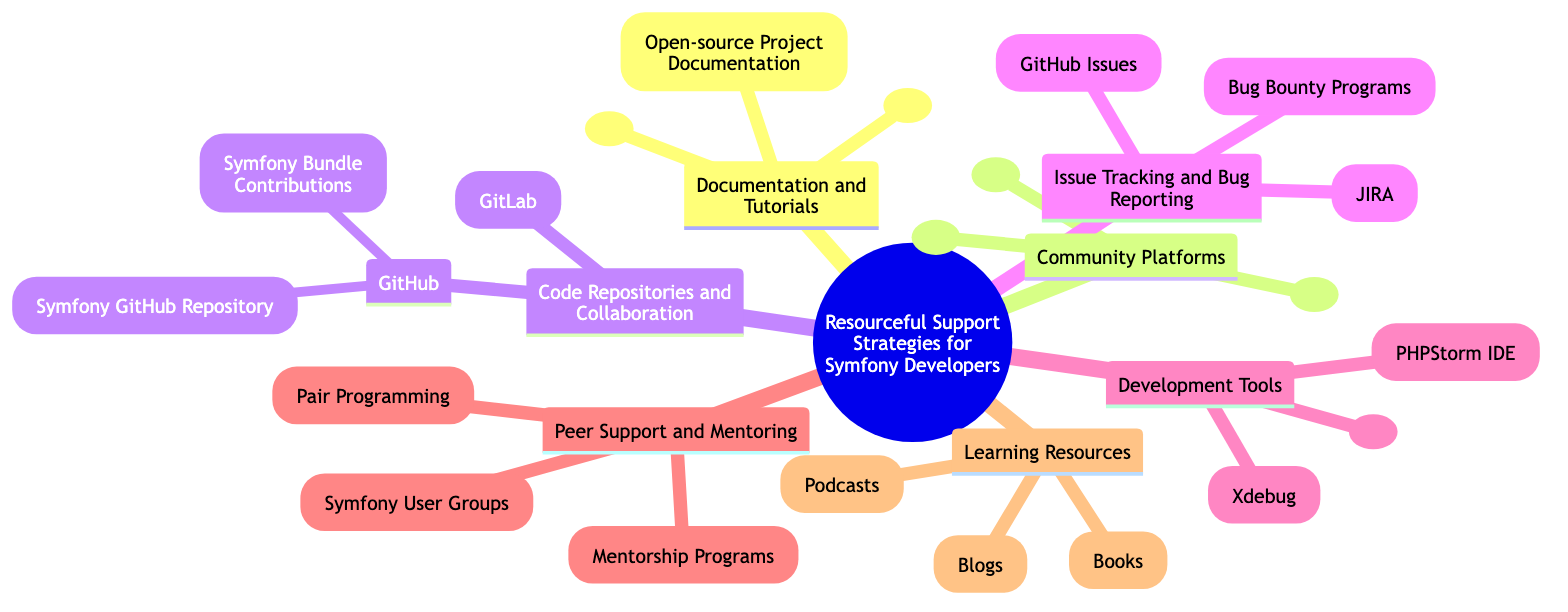What are the main areas of support strategies for Symfony developers? The main areas listed in the diagram include Documentation and Tutorials, Community Platforms, Code Repositories and Collaboration, Issue Tracking and Bug Reporting, Development Tools, Peer Support and Mentoring, and Learning Resources.
Answer: Documentation and Tutorials, Community Platforms, Code Repositories and Collaboration, Issue Tracking and Bug Reporting, Development Tools, Peer Support and Mentoring, Learning Resources How many community platforms are mentioned in the diagram? The community platforms include Symfony Slack, Stack Overflow, and Reddit Symfony Community. By counting these components, we find there are three community platforms.
Answer: 3 Which development tool is specifically provided with a link? The Symfony CLI is the only specific development tool that includes a link to its download page in the diagram.
Answer: Symfony CLI What types of resources fall under Learning Resources? Learning Resources are categorized into Blogs, Podcasts, and Books. By identifying the elements in this section of the diagram, we can confirm these three types of resources.
Answer: Blogs, Podcasts, Books What distinguishes GitHub Issues from JIRA in the context of issue tracking? GitHub Issues is specified for reporting issues and feature requests on Symfony's GitHub, while JIRA is mentioned as a tool for tracking issues in larger projects. This differentiation highlights their respective focuses, with GitHub Issues being for the Symfony project specifically and JIRA for larger project contexts.
Answer: GitHub Issues for Symfony, JIRA for larger projects What collaborative technique is used for enhancing problem-solving among Symfony developers? Pair Programming is mentioned as a technique that involves collaboration to solve complex problems. The diagram explicitly defines this collaborative method for enhancing problem-solving in the developer community.
Answer: Pair Programming How can Symfony developers contribute to open-source projects according to the diagram? Symfony developers can contribute by improving project documentation and creating and maintaining reusable bundles in the Code Repositories and Collaboration section. By analyzing these components, we see two methods of contribution.
Answer: Improving documentation, creating bundles What is a recommended method for finding mentorship opportunities in the Symfony community? Joining Symfony User Groups is highlighted as a way to find mentorship opportunities within the Symfony community. By traversing the Peer Support and Mentoring section, we identify this method as a point of access for mentorship.
Answer: Joining Symfony User Groups 